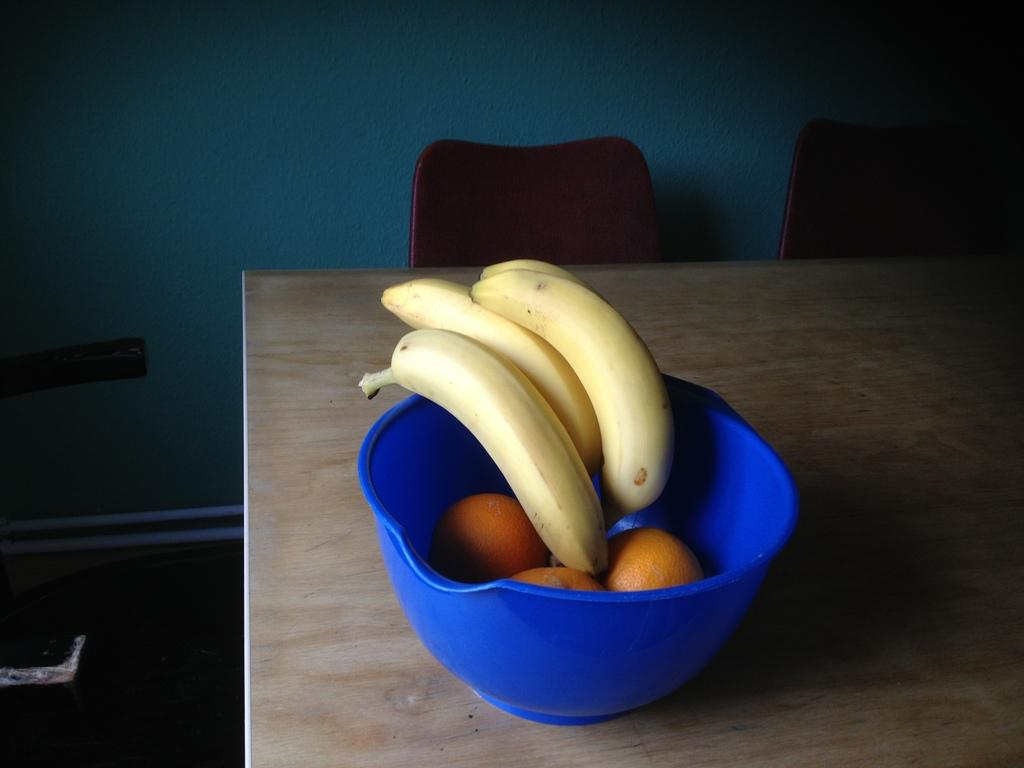What is located in the center of the image? There is a bowl in the center of the image. What is inside the bowl? The bowl contains bananas and oranges. Where is the bowl placed? The bowl is placed on a table. What can be seen in the background of the image? There are chairs and a wall visible in the background of the image. What type of flame can be seen coming from the bananas in the image? There is no flame present in the image; it features a bowl with bananas and oranges on a table. 